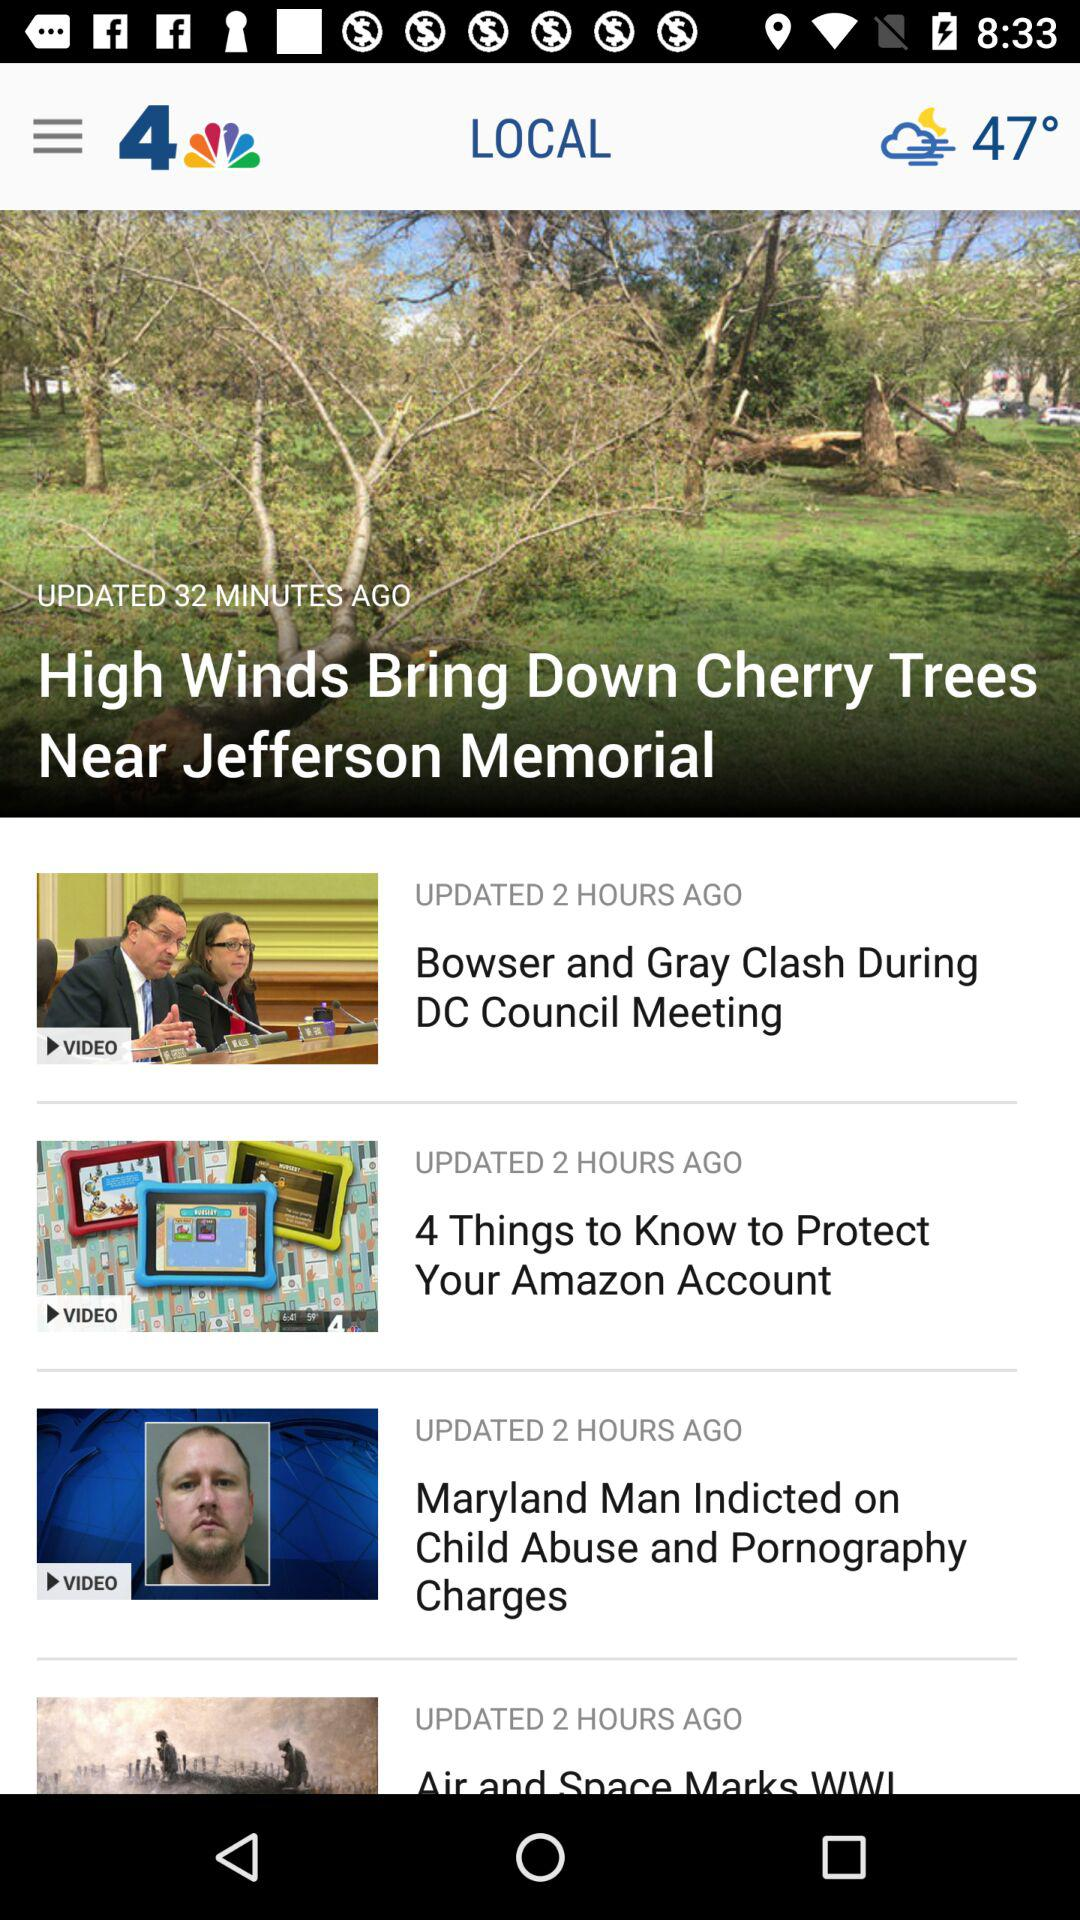What is the temperature? The temperature is 47 degrees. 